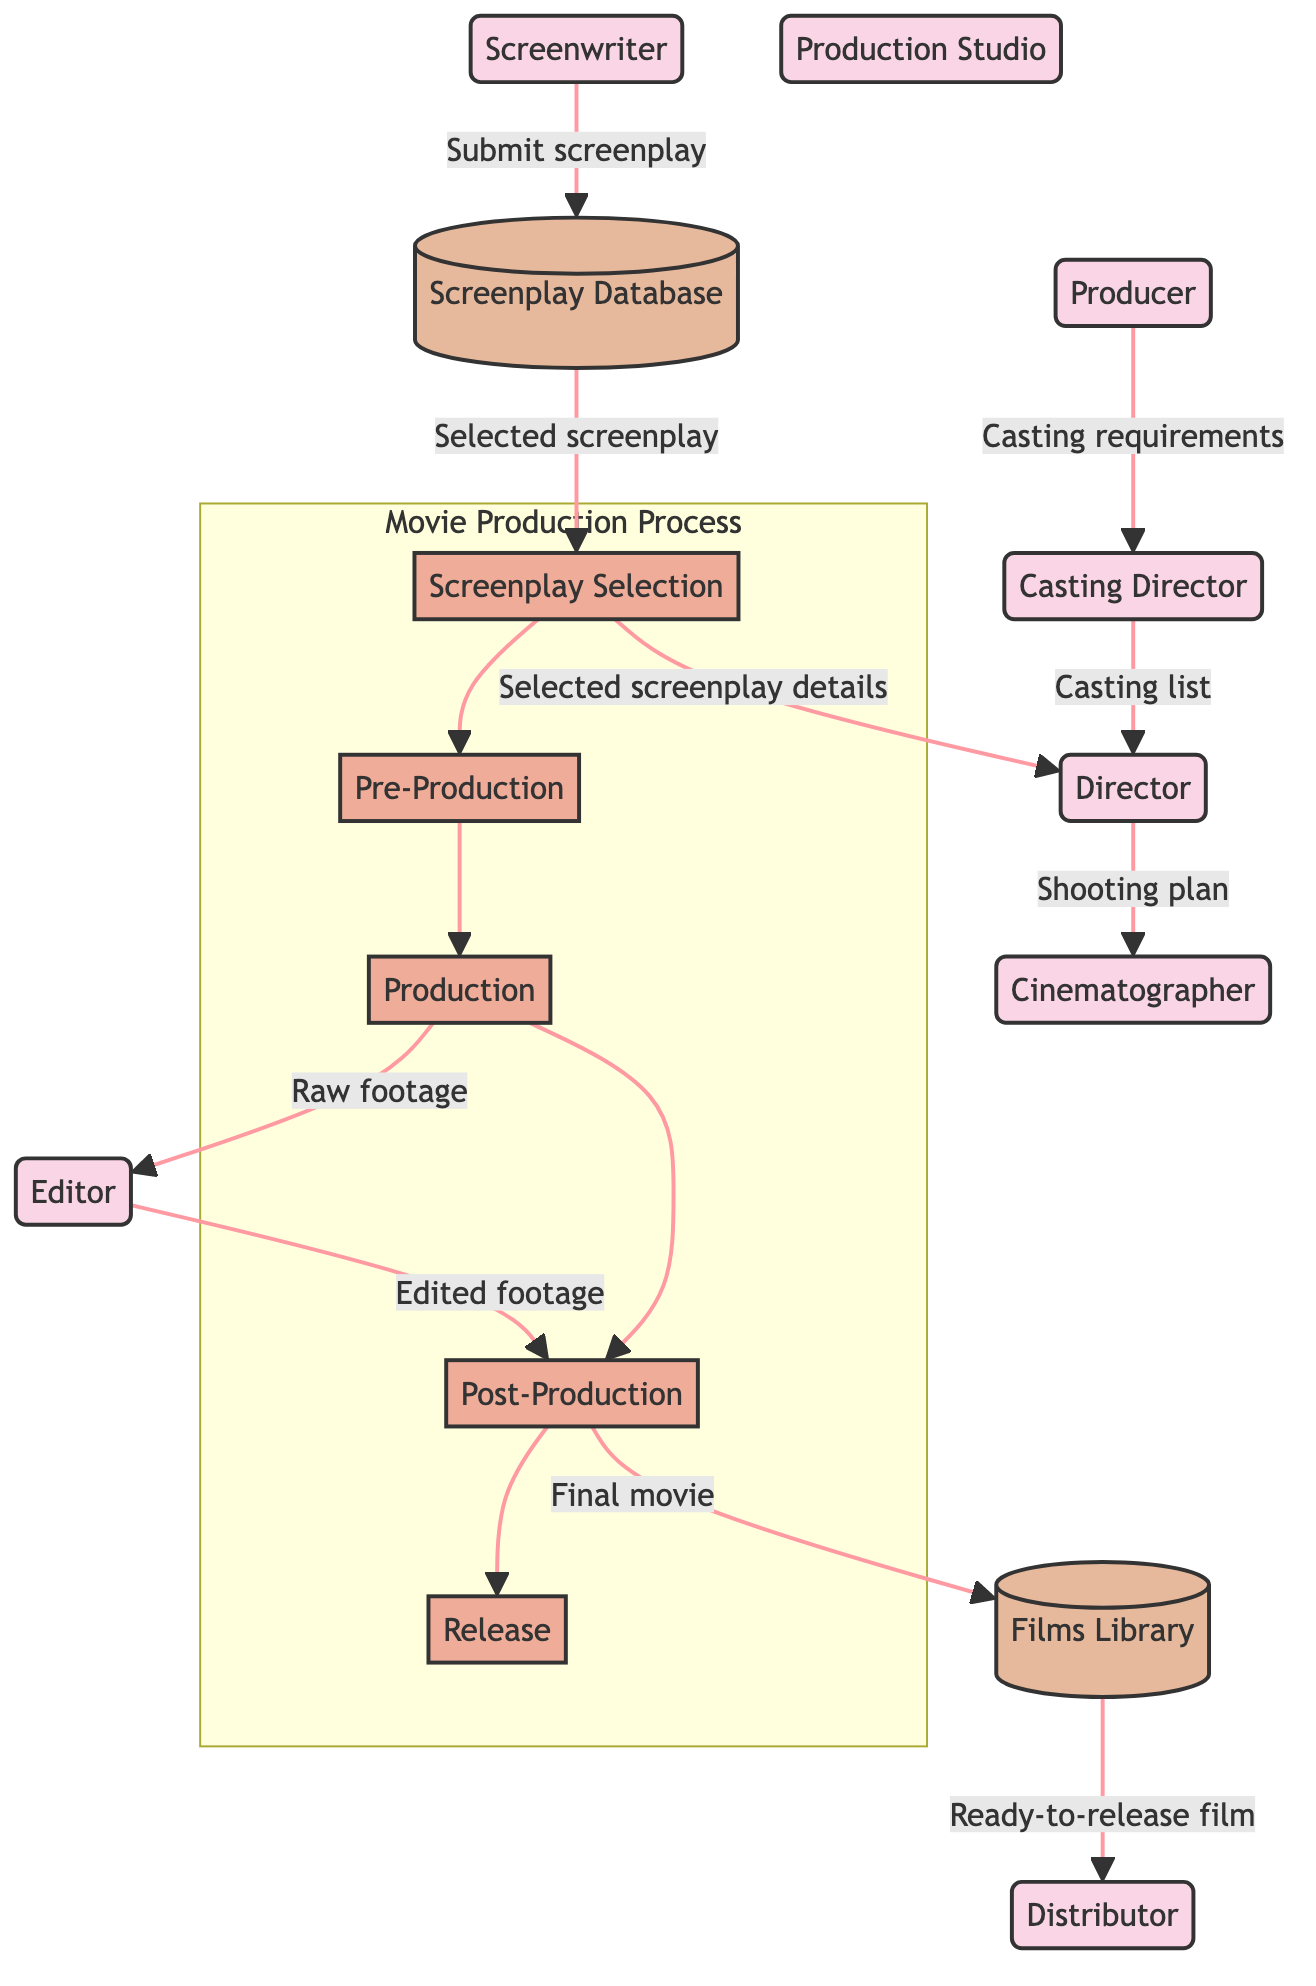What role does the Screenwriter play in the diagram? The Screenwriter submits screenplay to the Screenplay Database, making them integral to the screenplay selection process.
Answer: Submit screenplay How many processes are depicted in the diagram? There are five distinct processes: Screenplay Selection, Pre-Production, Production, Post-Production, and Release. Adding them gives a total of five.
Answer: Five What does the Producer provide to the Casting Director? The Producer provides the casting requirements, which guide the Casting Director in selecting actors for the film.
Answer: Casting requirements What is the flow from the Editor to the Post-Production process? The Editor sends edited footage as input to the Post-Production process, indicating that the editing is a key step before finalization.
Answer: Edited footage Which entity receives the final movie from Post-Production? The Films Library receives the final movie after post-production, storing it as part of the completed films collection.
Answer: Films Library What information does the Director receive from the Screenplay Selection? The Director receives selected screenplay details from the Screenplay Selection process, influencing their creative direction.
Answer: Selected screenplay details What is the primary purpose of the Distributor in this diagram? The Distributor's role is to release the movie to audiences, typically by delivering it to theaters or other platforms.
Answer: Release How does the Cinematographer contribute to the movie production? The Cinematographer receives the shooting plan from the Director, which details how the movie will be filmed.
Answer: Shooting plan What type of information flow occurs from the Films Library to the Distributor? The flow involves the transfer of a ready-to-release film from the Films Library to the Distributor, which is essential for movie distribution.
Answer: Ready-to-release film 